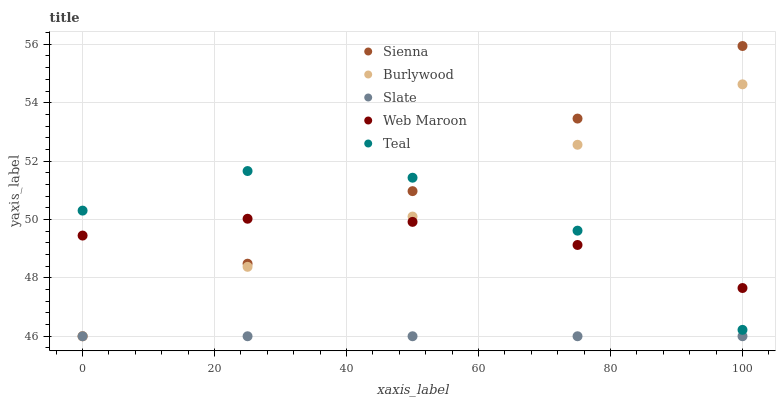Does Slate have the minimum area under the curve?
Answer yes or no. Yes. Does Sienna have the maximum area under the curve?
Answer yes or no. Yes. Does Burlywood have the minimum area under the curve?
Answer yes or no. No. Does Burlywood have the maximum area under the curve?
Answer yes or no. No. Is Slate the smoothest?
Answer yes or no. Yes. Is Teal the roughest?
Answer yes or no. Yes. Is Burlywood the smoothest?
Answer yes or no. No. Is Burlywood the roughest?
Answer yes or no. No. Does Sienna have the lowest value?
Answer yes or no. Yes. Does Web Maroon have the lowest value?
Answer yes or no. No. Does Sienna have the highest value?
Answer yes or no. Yes. Does Burlywood have the highest value?
Answer yes or no. No. Is Slate less than Web Maroon?
Answer yes or no. Yes. Is Teal greater than Slate?
Answer yes or no. Yes. Does Sienna intersect Burlywood?
Answer yes or no. Yes. Is Sienna less than Burlywood?
Answer yes or no. No. Is Sienna greater than Burlywood?
Answer yes or no. No. Does Slate intersect Web Maroon?
Answer yes or no. No. 